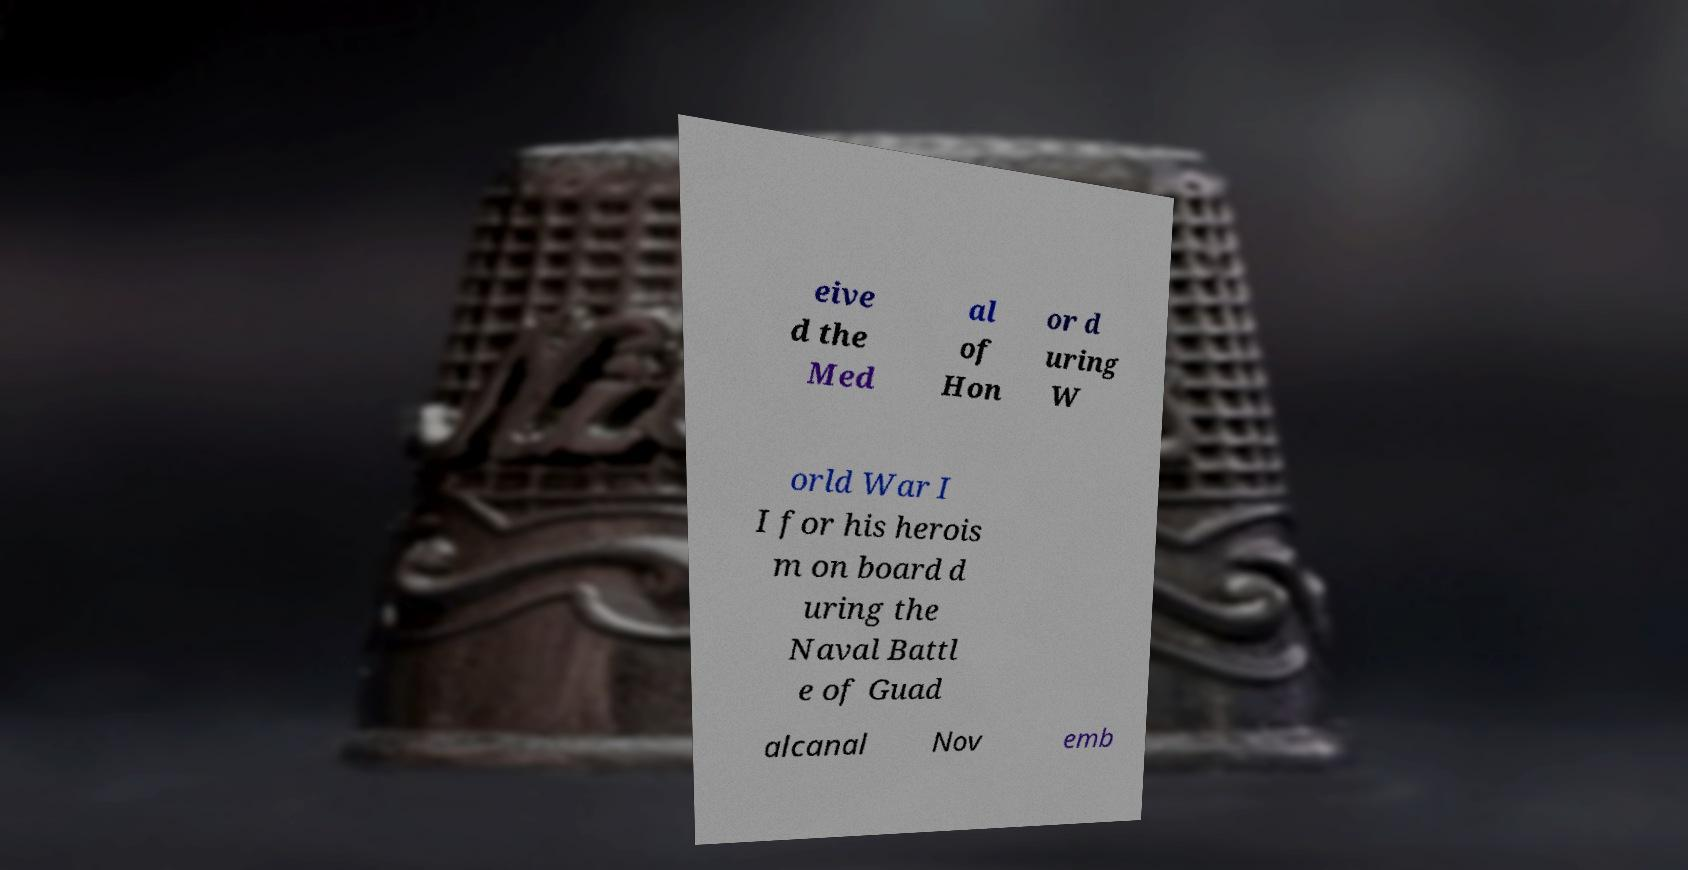There's text embedded in this image that I need extracted. Can you transcribe it verbatim? eive d the Med al of Hon or d uring W orld War I I for his herois m on board d uring the Naval Battl e of Guad alcanal Nov emb 